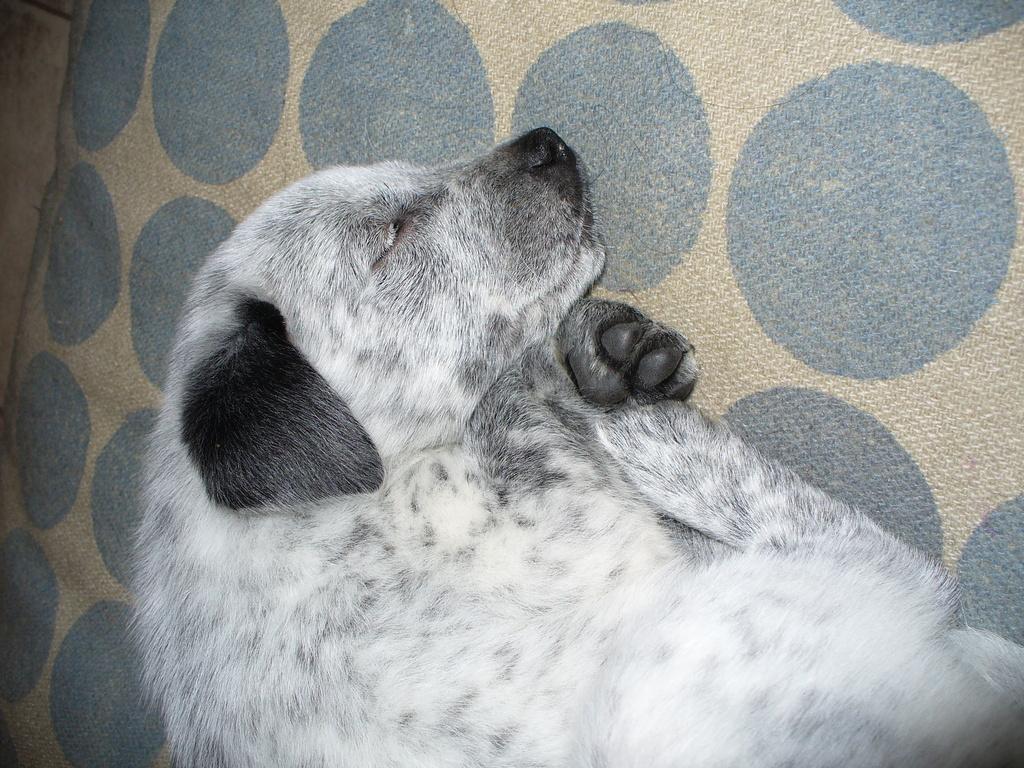Can you describe this image briefly? In this image in the center there is one dog which is sleeping, and in the background there is a mat. 